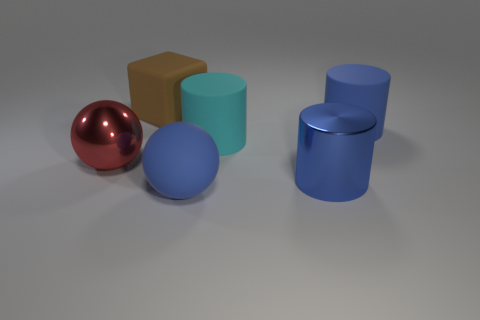Add 2 large blue cylinders. How many objects exist? 8 Subtract all cubes. How many objects are left? 5 Add 2 shiny cylinders. How many shiny cylinders are left? 3 Add 2 large matte cylinders. How many large matte cylinders exist? 4 Subtract 0 yellow cubes. How many objects are left? 6 Subtract all rubber cylinders. Subtract all red shiny balls. How many objects are left? 3 